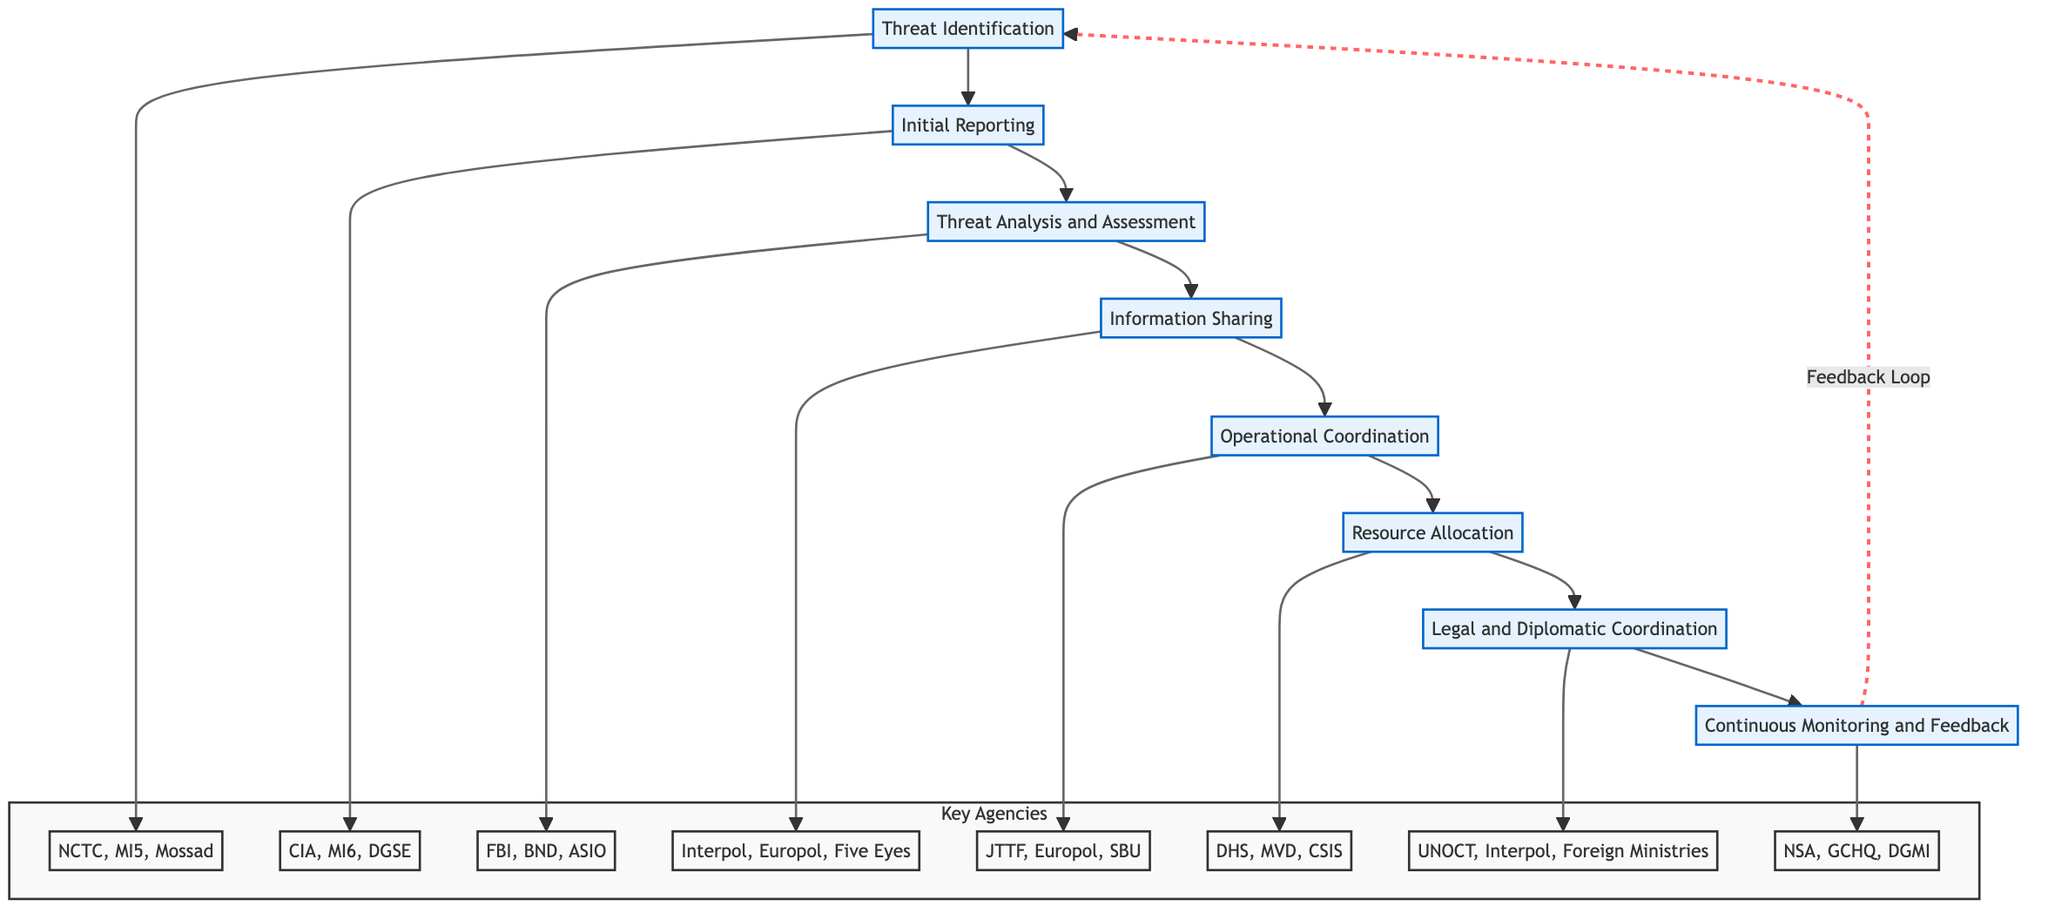What is the first step in the coordination process? The first step mentioned in the diagram is "Threat Identification," which outlines the process of collecting intelligence on potential terrorism threats.
Answer: Threat Identification How many total steps are there in the coordination process? The diagram contains a total of eight steps listed sequentially from Threat Identification to Continuous Monitoring and Feedback.
Answer: Eight What agency is responsible for "Information Sharing"? Referring to the diagram, "Information Sharing" is noted to be the responsibility of Interpol, Europol, and Five Eyes, as indicated in the respective node.
Answer: Interpol, Europol, Five Eyes What is the relationship between "Threat Analysis and Assessment" and "Initial Reporting"? The diagram shows a direct flow from "Initial Reporting" to "Threat Analysis and Assessment," indicating that the reporting must occur before any analysis can take place.
Answer: Direct flow Which step is connected to "Continuous Monitoring and Feedback" for improvement? The diagram indicates that "Continuous Monitoring and Feedback" provides feedback that returns to initiate "Threat Identification," highlighting a cyclical process of improvement.
Answer: Threat Identification What agencies are involved in the "Operational Coordination" step? The "Operational Coordination" step is associated with the Joint Terrorism Task Force, Europol, and Security Service of Ukraine, as depicted within the diagram.
Answer: JTTF, Europol, SBU Which agency is involved in "Legal and Diplomatic Coordination"? The agencies identified in the "Legal and Diplomatic Coordination" step are the United Nations Office of Counter-Terrorism, Interpol, and foreign ministries, as specified in the diagram.
Answer: UNOCT, Interpol, Foreign Ministries What indicates the step number of "Resource Allocation"? The flow chart structure implies that "Resource Allocation" is the sixth step in the sequence, as it follows five prior steps outlined before it.
Answer: Sixth 